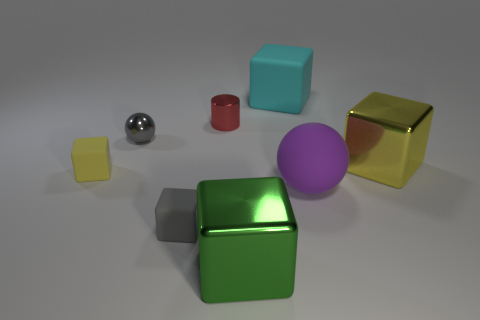Subtract all yellow cylinders. How many yellow cubes are left? 2 Subtract all green blocks. How many blocks are left? 4 Subtract 1 blocks. How many blocks are left? 4 Subtract all metal blocks. How many blocks are left? 3 Subtract all cyan cubes. Subtract all yellow spheres. How many cubes are left? 4 Add 1 tiny gray rubber objects. How many objects exist? 9 Subtract all blocks. How many objects are left? 3 Add 4 big metallic blocks. How many big metallic blocks are left? 6 Add 7 small blocks. How many small blocks exist? 9 Subtract 0 cyan spheres. How many objects are left? 8 